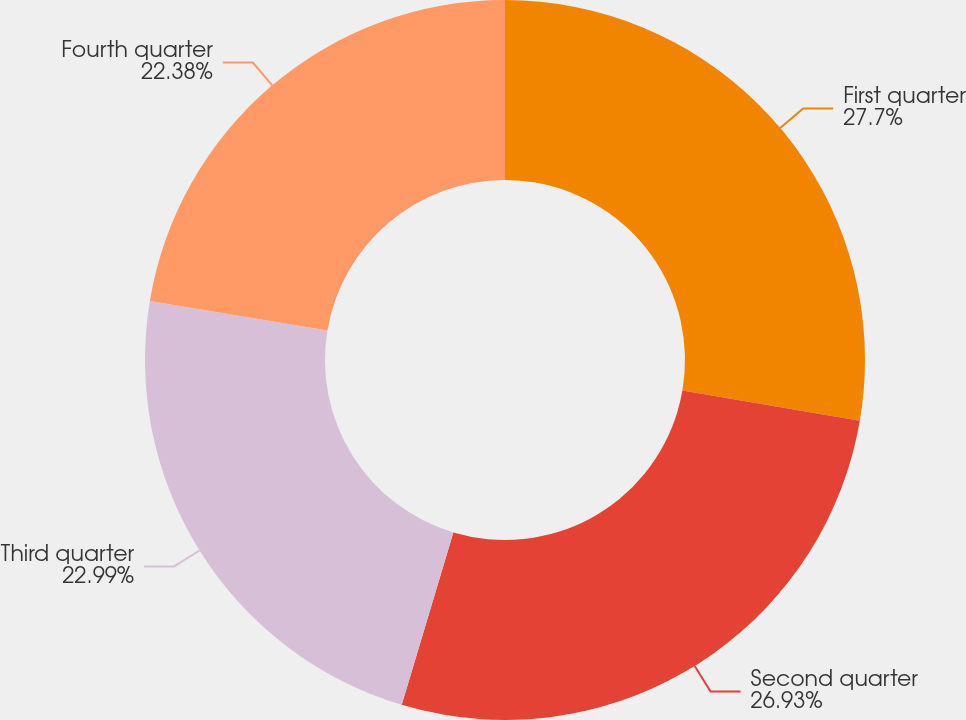Convert chart to OTSL. <chart><loc_0><loc_0><loc_500><loc_500><pie_chart><fcel>First quarter<fcel>Second quarter<fcel>Third quarter<fcel>Fourth quarter<nl><fcel>27.7%<fcel>26.93%<fcel>22.99%<fcel>22.38%<nl></chart> 